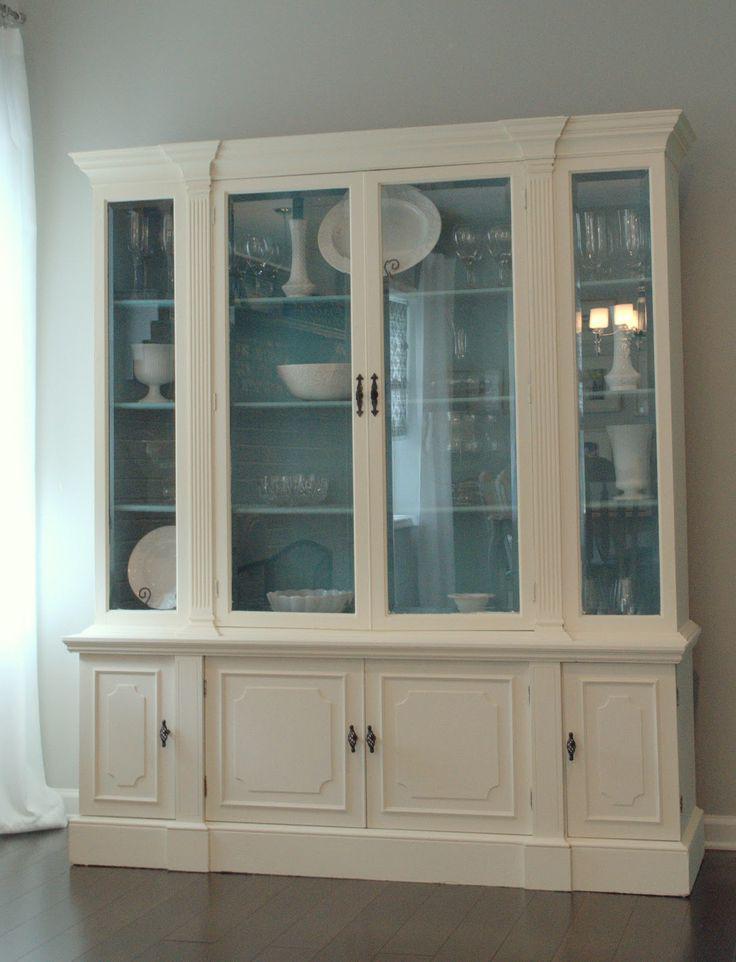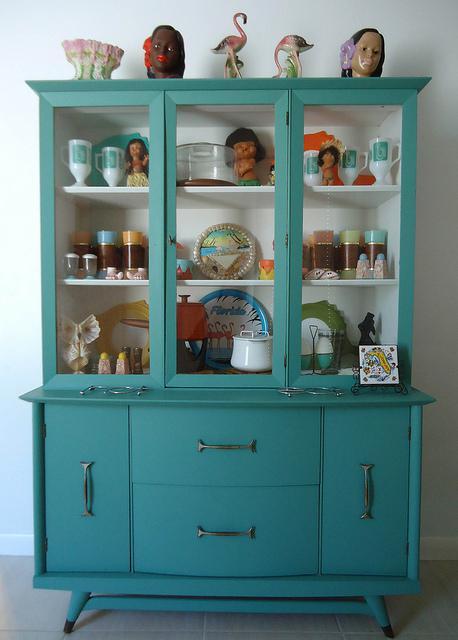The first image is the image on the left, the second image is the image on the right. Given the left and right images, does the statement "An image shows exactly one cabinet, which is sky blue." hold true? Answer yes or no. Yes. The first image is the image on the left, the second image is the image on the right. Analyze the images presented: Is the assertion "The blue colored cabinet is storing things." valid? Answer yes or no. Yes. 